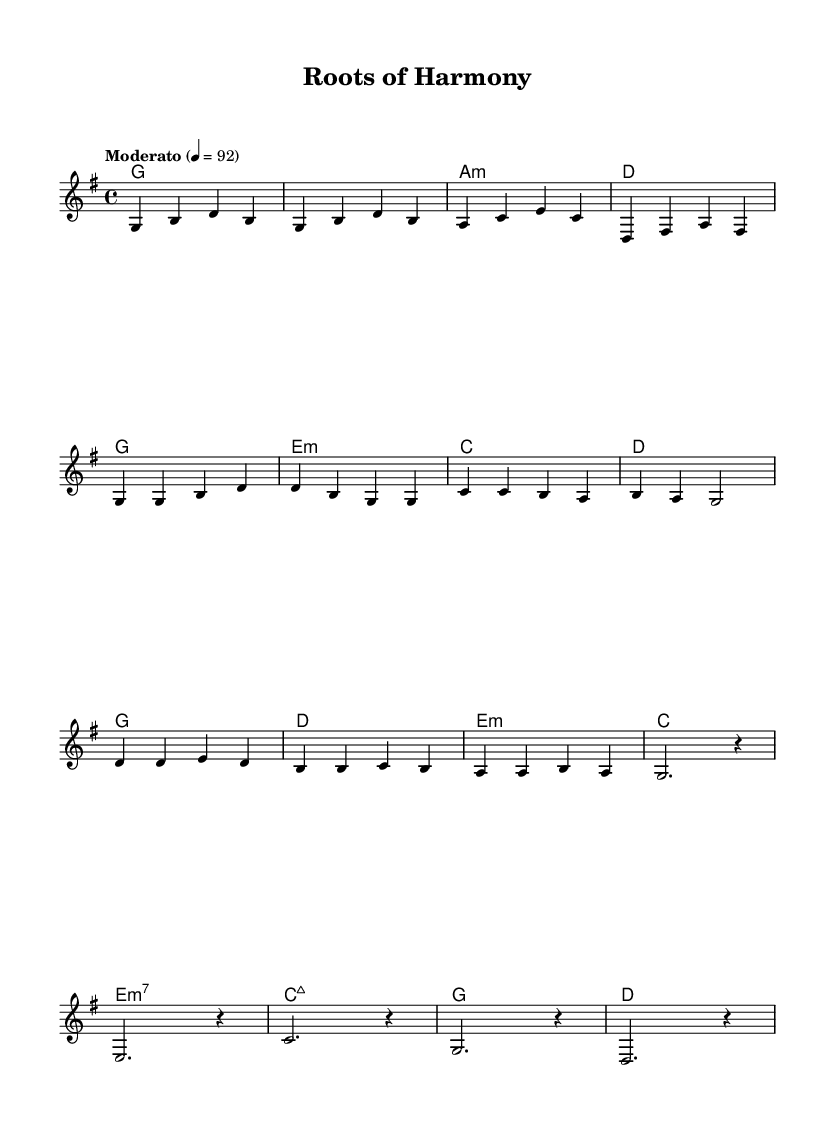What is the key signature of this music? The key signature is G major, which has one sharp (F#). This can be identified from the beginning of the sheet music where the key signature is indicated.
Answer: G major What is the time signature of the piece? The time signature is 4/4, indicated at the beginning of the sheet music. This means there are four beats in each measure and the quarter note receives one beat.
Answer: 4/4 What is the tempo marking for the piece? The tempo marking is "Moderato," indicated in the score. This means it should be played at a moderate speed. Additionally, the marking "4 = 92" suggests that the quarter note equals 92 beats per minute.
Answer: Moderato How many measures are in the chorus section of the song? To determine the number of measures in the chorus, we can analyze the notation in that section. By counting the measures written in the chorus, we find there are 4 measures total.
Answer: 4 What chords are used in the bridge section? The bridge section shows the chords e minor 7, C major 7, G major, and D major. These chord symbols are listed under the bridge section of the score, indicating what harmonies accompany that part.
Answer: e minor 7, C major 7, G major, D major Which chord appears most frequently in the song? By reviewing the entire score and counting the occurrences of each chord, G major appears the most frequently in both the verse and chorus sections. This shows its significant role in the harmony of the piece.
Answer: G major What is the last note played in the melody? The last note in the melody is a rest, indicated by 'r,' which signifies a pause in the music instead of a played note. It is essential to note the ending of the melody, which completes the piece.
Answer: rest 